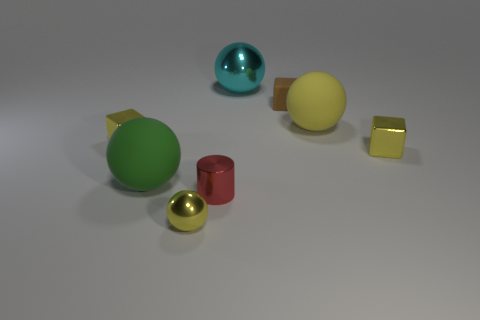The rubber object that is the same color as the tiny shiny ball is what size?
Offer a terse response. Large. Are there any cubes that have the same color as the tiny sphere?
Offer a very short reply. Yes. What is the shape of the large rubber thing that is the same color as the small sphere?
Offer a terse response. Sphere. There is a yellow shiny object that is right of the large cyan metallic thing; what is its shape?
Offer a terse response. Cube. What number of brown things are either small cylinders or matte balls?
Provide a short and direct response. 0. Are the brown cube and the green object made of the same material?
Your answer should be compact. Yes. There is a small red thing; what number of cyan metal things are on the left side of it?
Offer a very short reply. 0. The object that is behind the yellow rubber ball and right of the large shiny object is made of what material?
Offer a very short reply. Rubber. How many blocks are small matte things or tiny red objects?
Keep it short and to the point. 1. What material is the large green thing that is the same shape as the big yellow object?
Offer a very short reply. Rubber. 